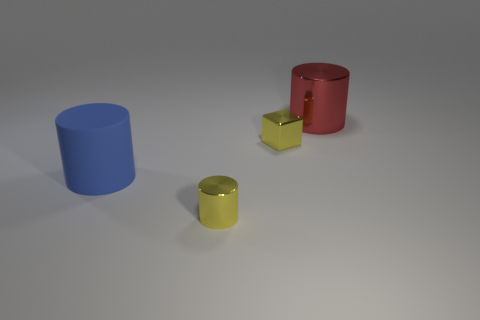What is the size of the red metallic thing that is the same shape as the blue object?
Offer a terse response. Large. Are there any cylinders behind the large red shiny thing?
Your answer should be compact. No. Are there the same number of yellow metallic things on the right side of the large shiny thing and big rubber cylinders?
Your answer should be compact. No. There is a yellow thing that is right of the yellow thing in front of the big blue matte cylinder; are there any yellow things that are left of it?
Provide a succinct answer. Yes. What is the material of the big blue cylinder?
Offer a terse response. Rubber. What number of other things are there of the same shape as the matte object?
Give a very brief answer. 2. Does the big matte thing have the same shape as the large shiny thing?
Your answer should be compact. Yes. What number of things are tiny yellow shiny objects in front of the blue matte cylinder or metal objects that are behind the tiny cylinder?
Your response must be concise. 3. How many things are big purple shiny cylinders or large cylinders?
Offer a terse response. 2. What number of tiny yellow things are right of the cylinder behind the rubber cylinder?
Offer a terse response. 0. 